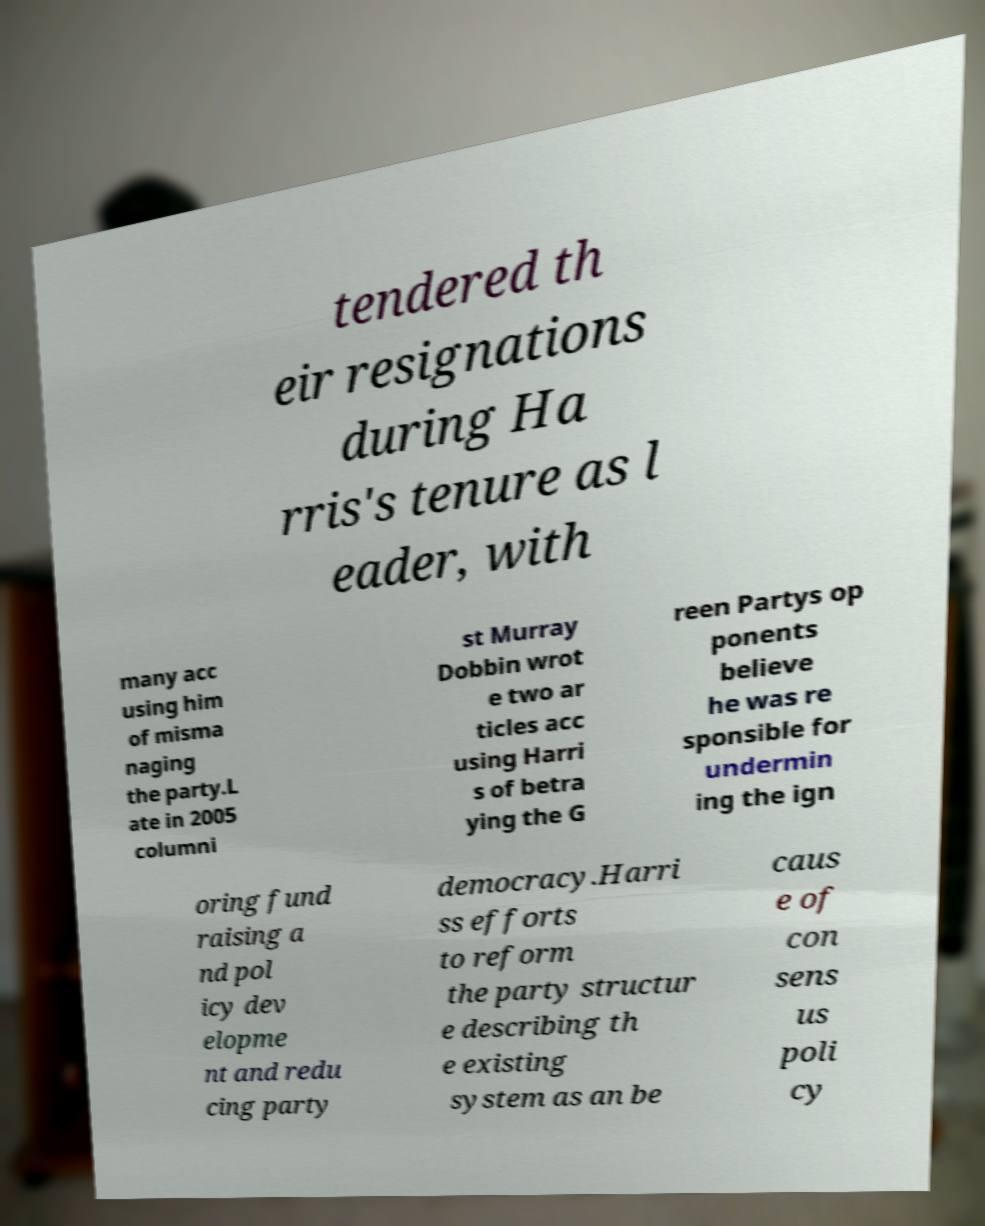Please identify and transcribe the text found in this image. tendered th eir resignations during Ha rris's tenure as l eader, with many acc using him of misma naging the party.L ate in 2005 columni st Murray Dobbin wrot e two ar ticles acc using Harri s of betra ying the G reen Partys op ponents believe he was re sponsible for undermin ing the ign oring fund raising a nd pol icy dev elopme nt and redu cing party democracy.Harri ss efforts to reform the party structur e describing th e existing system as an be caus e of con sens us poli cy 